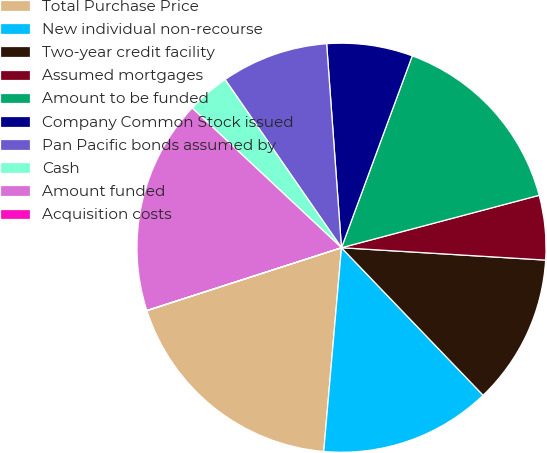Convert chart. <chart><loc_0><loc_0><loc_500><loc_500><pie_chart><fcel>Total Purchase Price<fcel>New individual non-recourse<fcel>Two-year credit facility<fcel>Assumed mortgages<fcel>Amount to be funded<fcel>Company Common Stock issued<fcel>Pan Pacific bonds assumed by<fcel>Cash<fcel>Amount funded<fcel>Acquisition costs<nl><fcel>18.64%<fcel>13.56%<fcel>11.86%<fcel>5.09%<fcel>15.25%<fcel>6.78%<fcel>8.48%<fcel>3.39%<fcel>16.94%<fcel>0.01%<nl></chart> 